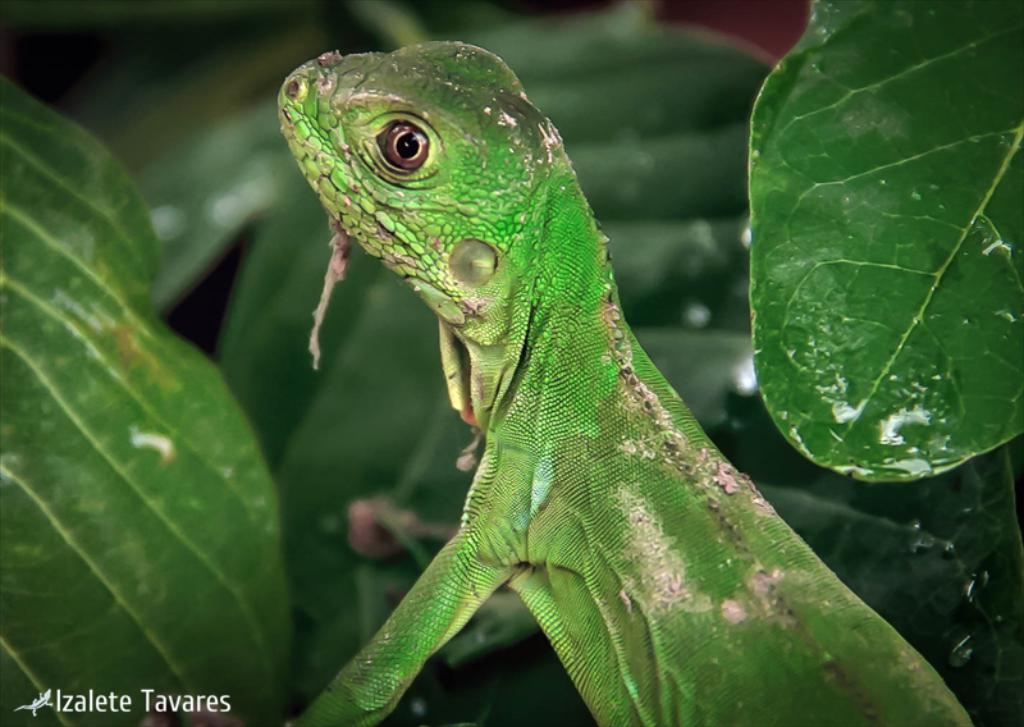What type of animal is in the image? There is a reptile in the image. What color is the reptile? The reptile is green in color. What can be seen in the background of the image? There are green leaves in the background of the image. How does the reptile show care and attention towards the leaves in the image? The image does not depict any emotions or actions from the reptile, so it cannot be determined how it might show care and attention towards the leaves. 